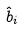Convert formula to latex. <formula><loc_0><loc_0><loc_500><loc_500>\hat { b } _ { i }</formula> 